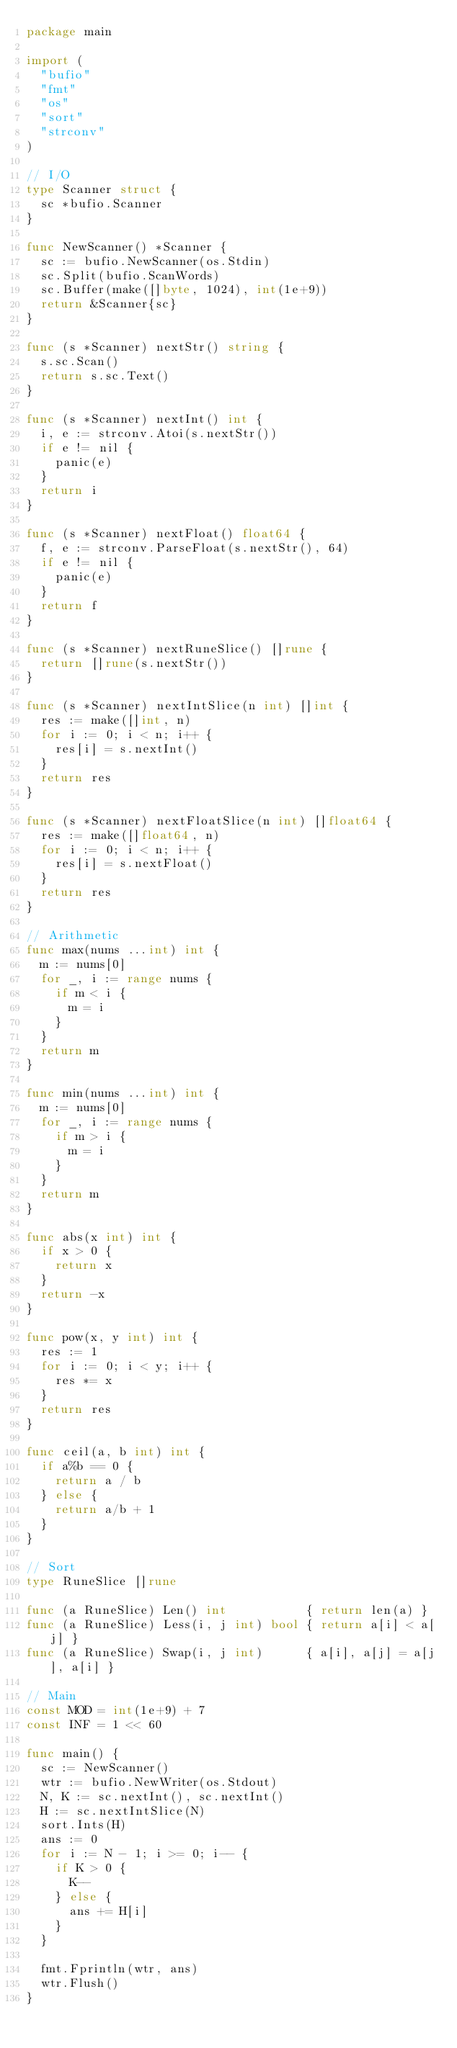Convert code to text. <code><loc_0><loc_0><loc_500><loc_500><_Go_>package main

import (
	"bufio"
	"fmt"
	"os"
	"sort"
	"strconv"
)

// I/O
type Scanner struct {
	sc *bufio.Scanner
}

func NewScanner() *Scanner {
	sc := bufio.NewScanner(os.Stdin)
	sc.Split(bufio.ScanWords)
	sc.Buffer(make([]byte, 1024), int(1e+9))
	return &Scanner{sc}
}

func (s *Scanner) nextStr() string {
	s.sc.Scan()
	return s.sc.Text()
}

func (s *Scanner) nextInt() int {
	i, e := strconv.Atoi(s.nextStr())
	if e != nil {
		panic(e)
	}
	return i
}

func (s *Scanner) nextFloat() float64 {
	f, e := strconv.ParseFloat(s.nextStr(), 64)
	if e != nil {
		panic(e)
	}
	return f
}

func (s *Scanner) nextRuneSlice() []rune {
	return []rune(s.nextStr())
}

func (s *Scanner) nextIntSlice(n int) []int {
	res := make([]int, n)
	for i := 0; i < n; i++ {
		res[i] = s.nextInt()
	}
	return res
}

func (s *Scanner) nextFloatSlice(n int) []float64 {
	res := make([]float64, n)
	for i := 0; i < n; i++ {
		res[i] = s.nextFloat()
	}
	return res
}

// Arithmetic
func max(nums ...int) int {
	m := nums[0]
	for _, i := range nums {
		if m < i {
			m = i
		}
	}
	return m
}

func min(nums ...int) int {
	m := nums[0]
	for _, i := range nums {
		if m > i {
			m = i
		}
	}
	return m
}

func abs(x int) int {
	if x > 0 {
		return x
	}
	return -x
}

func pow(x, y int) int {
	res := 1
	for i := 0; i < y; i++ {
		res *= x
	}
	return res
}

func ceil(a, b int) int {
	if a%b == 0 {
		return a / b
	} else {
		return a/b + 1
	}
}

// Sort
type RuneSlice []rune

func (a RuneSlice) Len() int           { return len(a) }
func (a RuneSlice) Less(i, j int) bool { return a[i] < a[j] }
func (a RuneSlice) Swap(i, j int)      { a[i], a[j] = a[j], a[i] }

// Main
const MOD = int(1e+9) + 7
const INF = 1 << 60

func main() {
	sc := NewScanner()
	wtr := bufio.NewWriter(os.Stdout)
	N, K := sc.nextInt(), sc.nextInt()
	H := sc.nextIntSlice(N)
	sort.Ints(H)
	ans := 0
	for i := N - 1; i >= 0; i-- {
		if K > 0 {
			K--
		} else {
			ans += H[i]
		}
	}

	fmt.Fprintln(wtr, ans)
	wtr.Flush()
}
</code> 